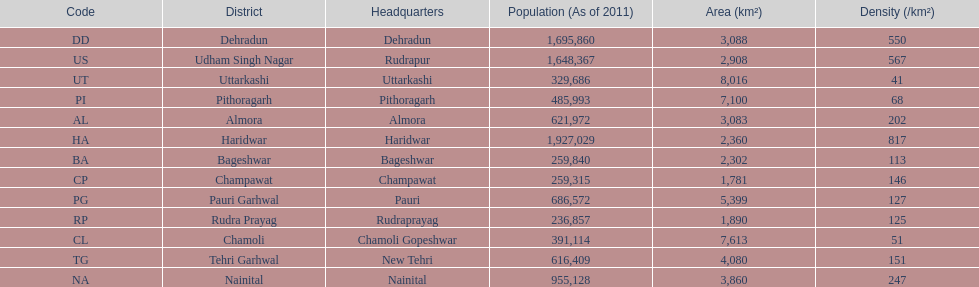How many total districts are there in this area? 13. 